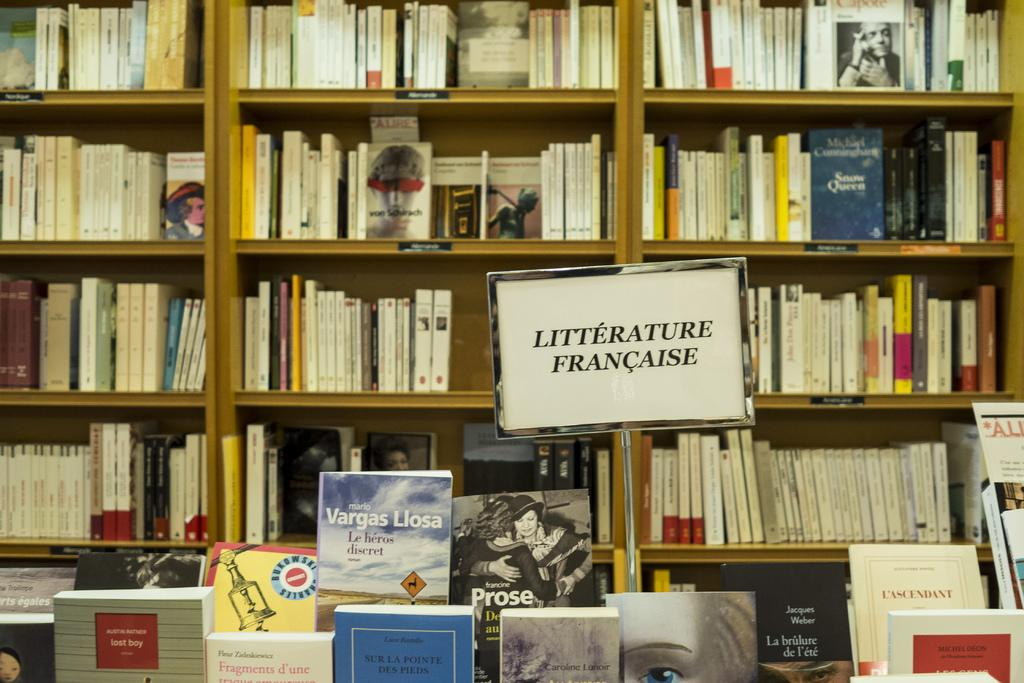What can be seen in the bookshelf in the image? There are books in a bookshelf in the image. What else is present in the image besides the bookshelf? There is a board with some text in the image. Where are some of the books located in the image? There are books at the bottom of the image. What type of machine is being smashed by the books in the image? There is no machine present in the image, nor are the books smashing anything. 